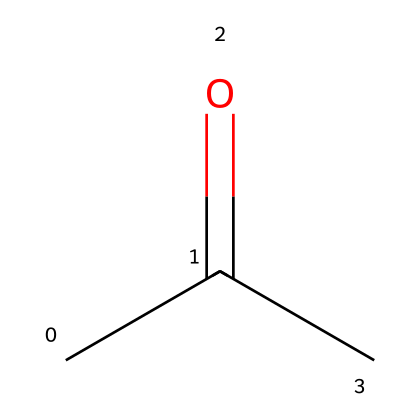What is the IUPAC name of this compound? The structure indicates that there are three carbon atoms, with a carbonyl functional group (C=O) and two methyl groups. Therefore, the IUPAC name is derived from propan-2-one.
Answer: acetone How many carbon atoms are present in this molecule? The SMILES structure CC(=O)C indicates there are three 'C' characters, which represent three carbon atoms in total.
Answer: 3 Is this compound polar or nonpolar? The presence of a polar carbonyl group (C=O) makes the overall molecule have a dipole moment, indicating that it is polar.
Answer: polar Can this compound conduct electricity? As a non-electrolyte, acetone does not dissociate into ions in solution, so it does not conduct electricity.
Answer: no What functional group is present in acetone? The structure shows a carbonyl (C=O) group, which is characteristic of ketones; thus, it is classified as a ketone due to this functional group.
Answer: carbonyl 